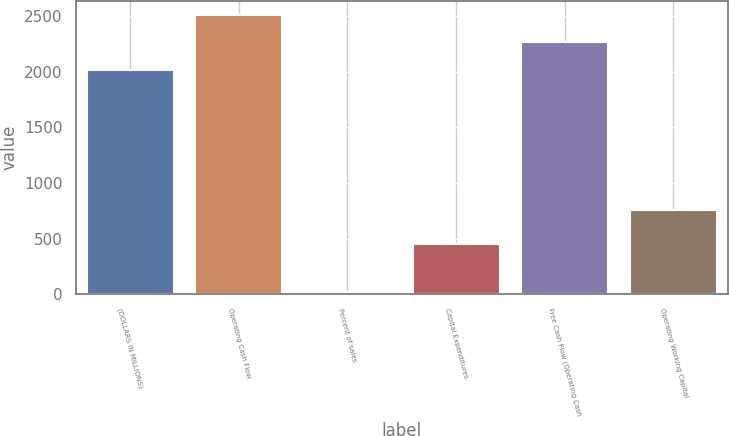<chart> <loc_0><loc_0><loc_500><loc_500><bar_chart><fcel>(DOLLARS IN MILLIONS)<fcel>Operating Cash Flow<fcel>Percent of sales<fcel>Capital Expenditures<fcel>Free Cash Flow (Operating Cash<fcel>Operating Working Capital<nl><fcel>2016<fcel>2512.36<fcel>17.2<fcel>447<fcel>2264.18<fcel>755<nl></chart> 